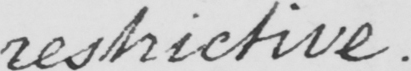What is written in this line of handwriting? restrictive . 